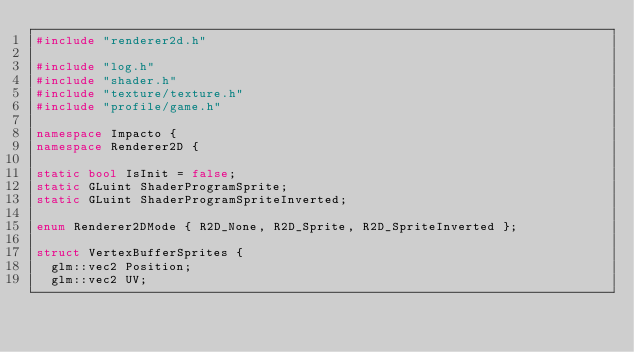<code> <loc_0><loc_0><loc_500><loc_500><_C++_>#include "renderer2d.h"

#include "log.h"
#include "shader.h"
#include "texture/texture.h"
#include "profile/game.h"

namespace Impacto {
namespace Renderer2D {

static bool IsInit = false;
static GLuint ShaderProgramSprite;
static GLuint ShaderProgramSpriteInverted;

enum Renderer2DMode { R2D_None, R2D_Sprite, R2D_SpriteInverted };

struct VertexBufferSprites {
  glm::vec2 Position;
  glm::vec2 UV;</code> 